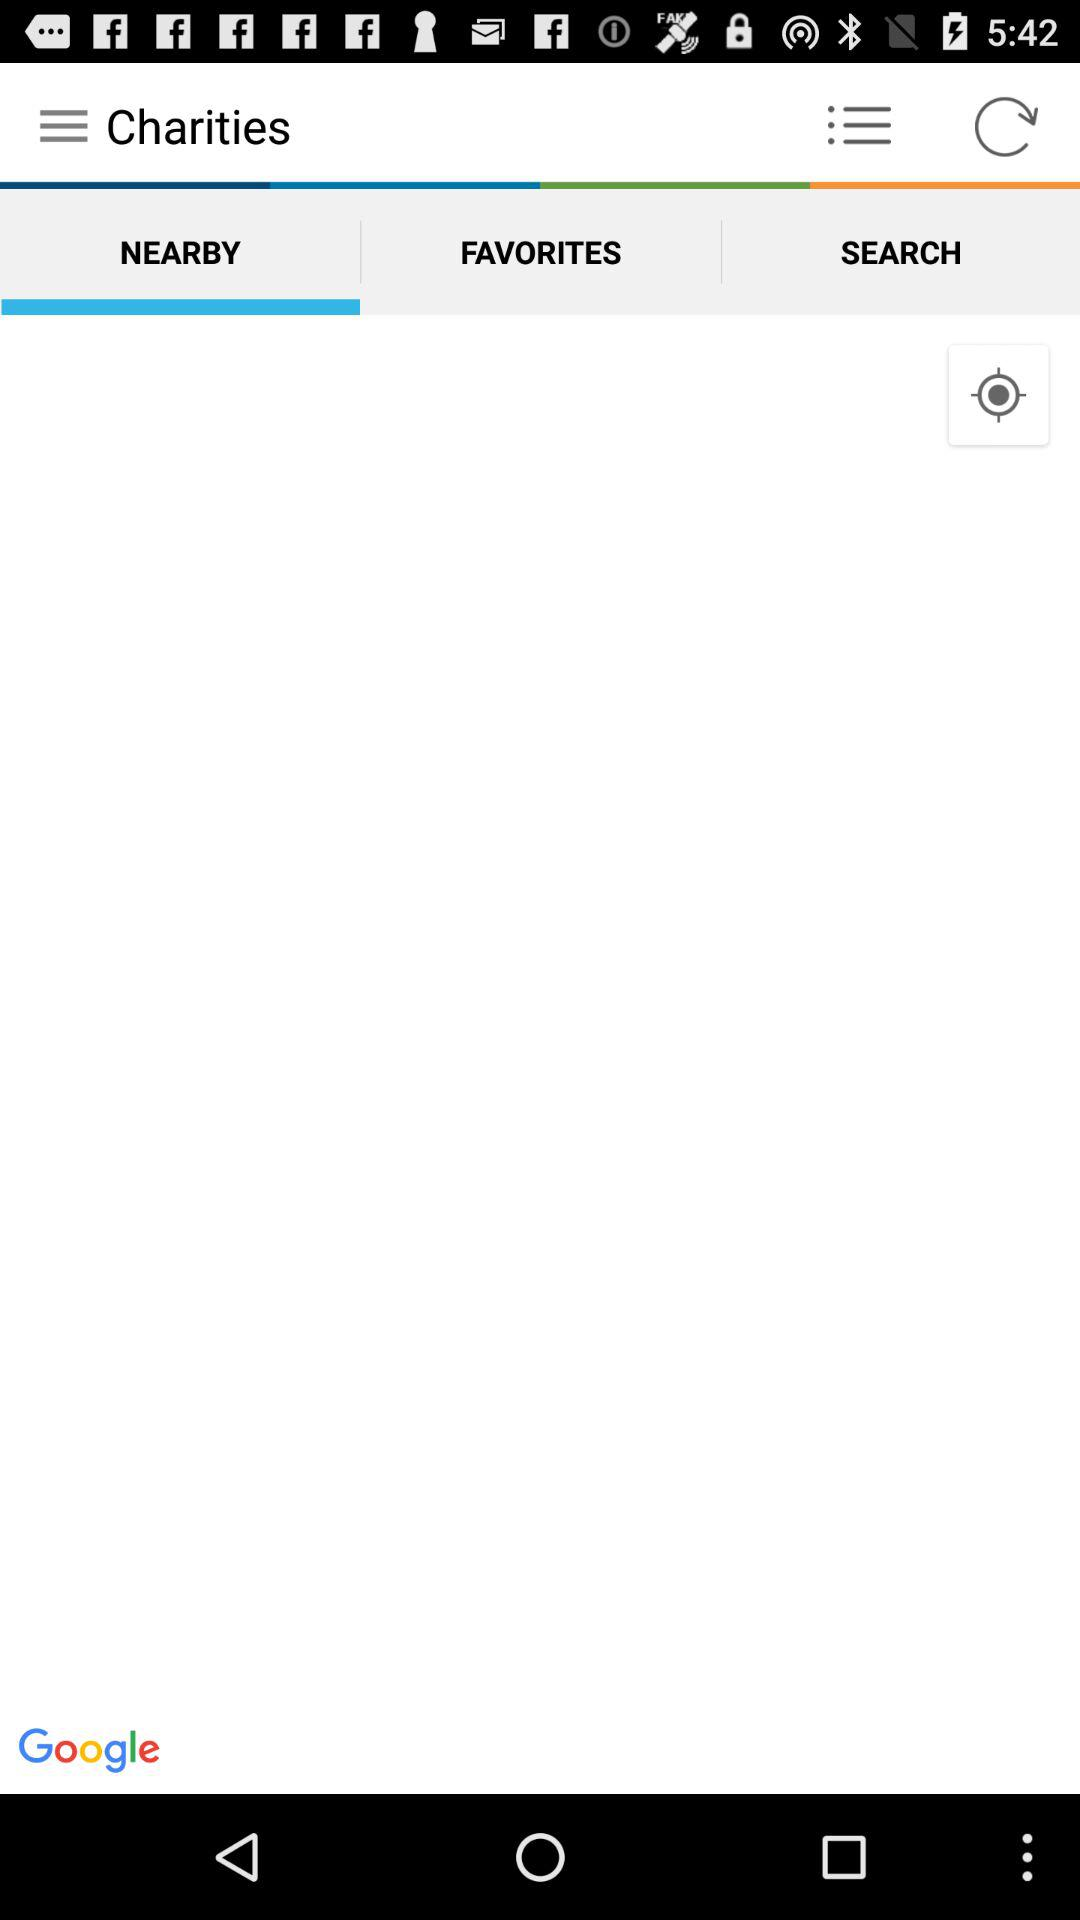When was the screen reloaded?
When the provided information is insufficient, respond with <no answer>. <no answer> 